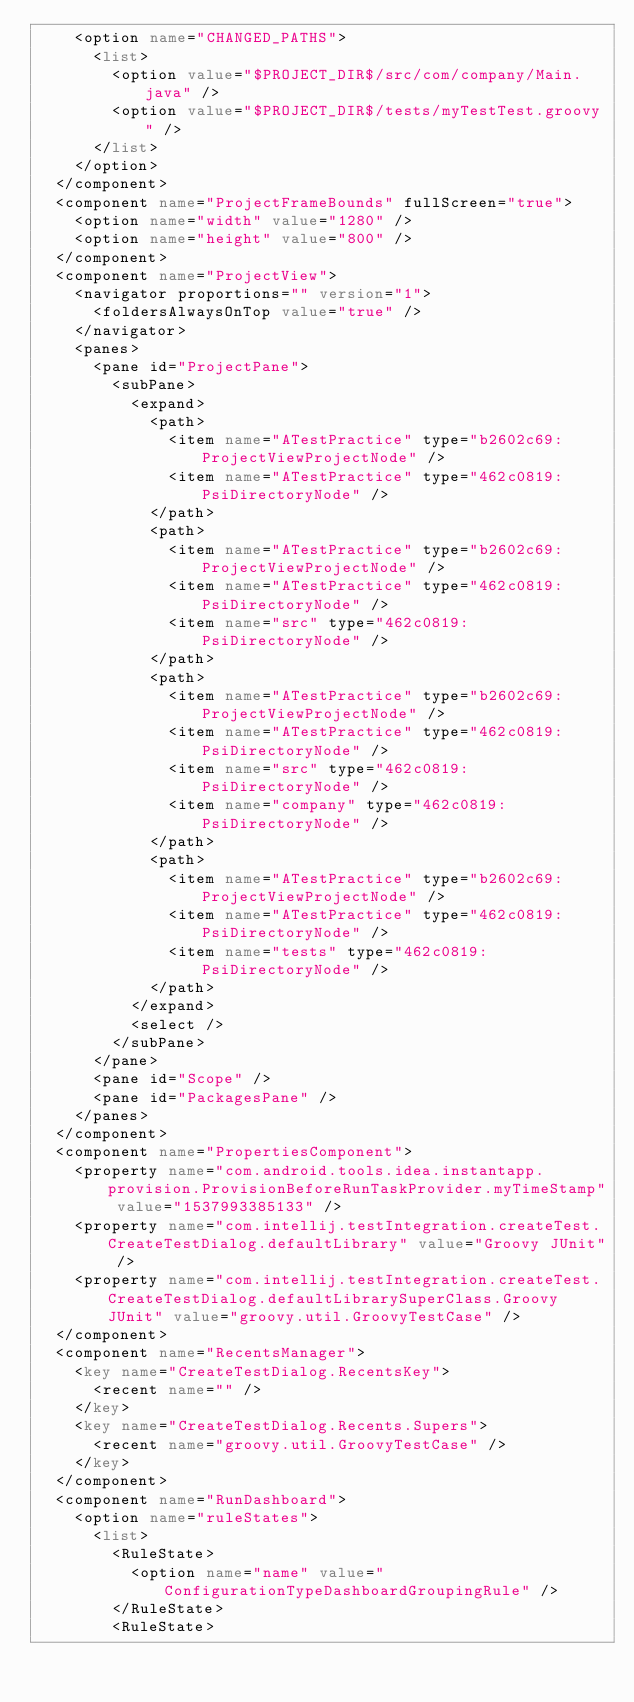<code> <loc_0><loc_0><loc_500><loc_500><_XML_>    <option name="CHANGED_PATHS">
      <list>
        <option value="$PROJECT_DIR$/src/com/company/Main.java" />
        <option value="$PROJECT_DIR$/tests/myTestTest.groovy" />
      </list>
    </option>
  </component>
  <component name="ProjectFrameBounds" fullScreen="true">
    <option name="width" value="1280" />
    <option name="height" value="800" />
  </component>
  <component name="ProjectView">
    <navigator proportions="" version="1">
      <foldersAlwaysOnTop value="true" />
    </navigator>
    <panes>
      <pane id="ProjectPane">
        <subPane>
          <expand>
            <path>
              <item name="ATestPractice" type="b2602c69:ProjectViewProjectNode" />
              <item name="ATestPractice" type="462c0819:PsiDirectoryNode" />
            </path>
            <path>
              <item name="ATestPractice" type="b2602c69:ProjectViewProjectNode" />
              <item name="ATestPractice" type="462c0819:PsiDirectoryNode" />
              <item name="src" type="462c0819:PsiDirectoryNode" />
            </path>
            <path>
              <item name="ATestPractice" type="b2602c69:ProjectViewProjectNode" />
              <item name="ATestPractice" type="462c0819:PsiDirectoryNode" />
              <item name="src" type="462c0819:PsiDirectoryNode" />
              <item name="company" type="462c0819:PsiDirectoryNode" />
            </path>
            <path>
              <item name="ATestPractice" type="b2602c69:ProjectViewProjectNode" />
              <item name="ATestPractice" type="462c0819:PsiDirectoryNode" />
              <item name="tests" type="462c0819:PsiDirectoryNode" />
            </path>
          </expand>
          <select />
        </subPane>
      </pane>
      <pane id="Scope" />
      <pane id="PackagesPane" />
    </panes>
  </component>
  <component name="PropertiesComponent">
    <property name="com.android.tools.idea.instantapp.provision.ProvisionBeforeRunTaskProvider.myTimeStamp" value="1537993385133" />
    <property name="com.intellij.testIntegration.createTest.CreateTestDialog.defaultLibrary" value="Groovy JUnit" />
    <property name="com.intellij.testIntegration.createTest.CreateTestDialog.defaultLibrarySuperClass.Groovy JUnit" value="groovy.util.GroovyTestCase" />
  </component>
  <component name="RecentsManager">
    <key name="CreateTestDialog.RecentsKey">
      <recent name="" />
    </key>
    <key name="CreateTestDialog.Recents.Supers">
      <recent name="groovy.util.GroovyTestCase" />
    </key>
  </component>
  <component name="RunDashboard">
    <option name="ruleStates">
      <list>
        <RuleState>
          <option name="name" value="ConfigurationTypeDashboardGroupingRule" />
        </RuleState>
        <RuleState></code> 